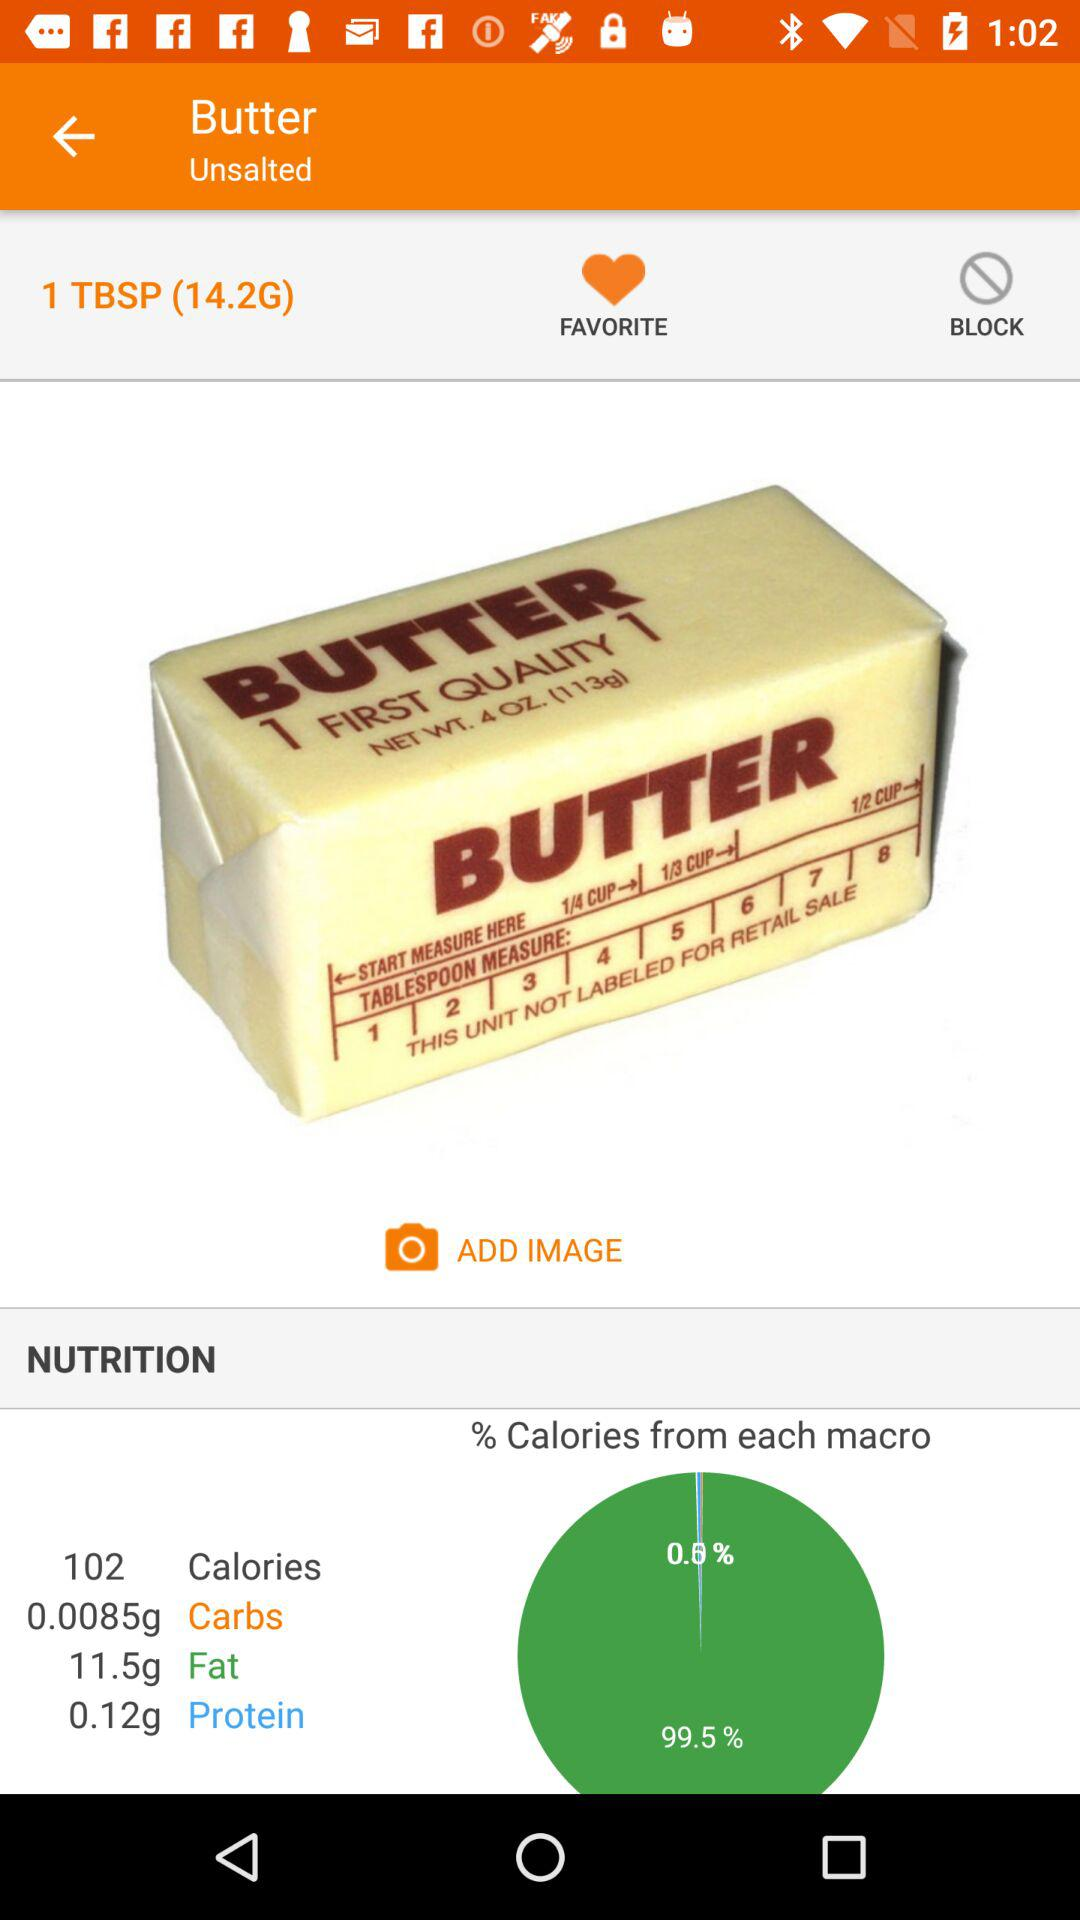How much is the protein content in butter? The protein content is 0.12 gm. 